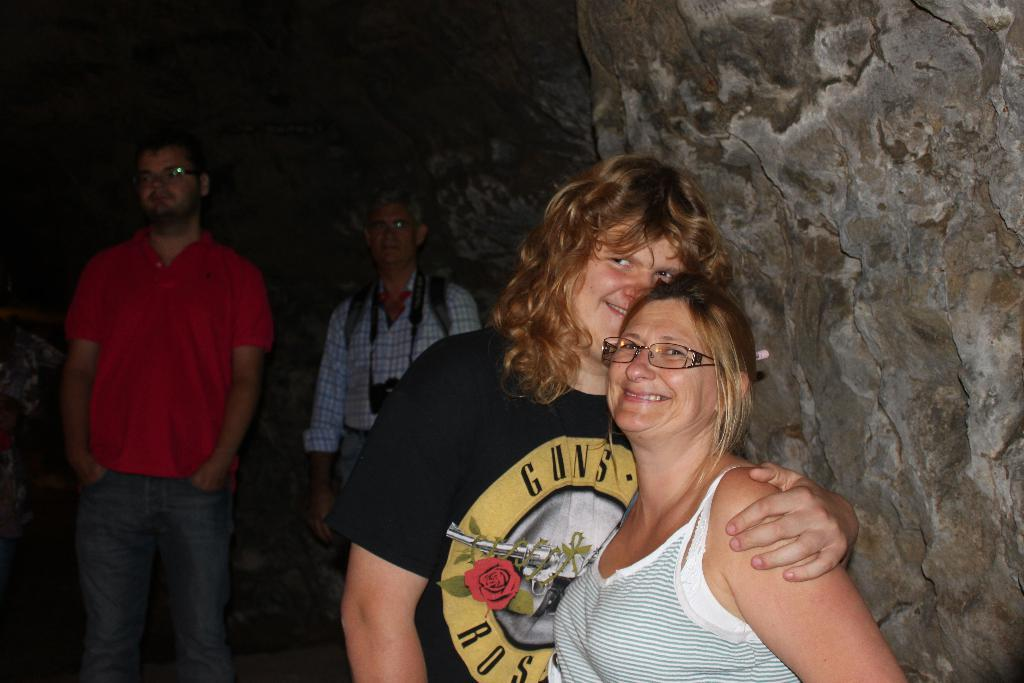How many people are in the image? There are four people in the image. What are the people in the middle of the image doing? The two people in the middle of the image are standing and smiling. What is behind the people in the middle of the image? There is a wall behind them. Where are the other two people located in the image? The other two people are standing at the bottom left side of the image. What type of butter can be seen melting on the sink in the image? There is no butter or sink present in the image; it only features four people standing and smiling. 